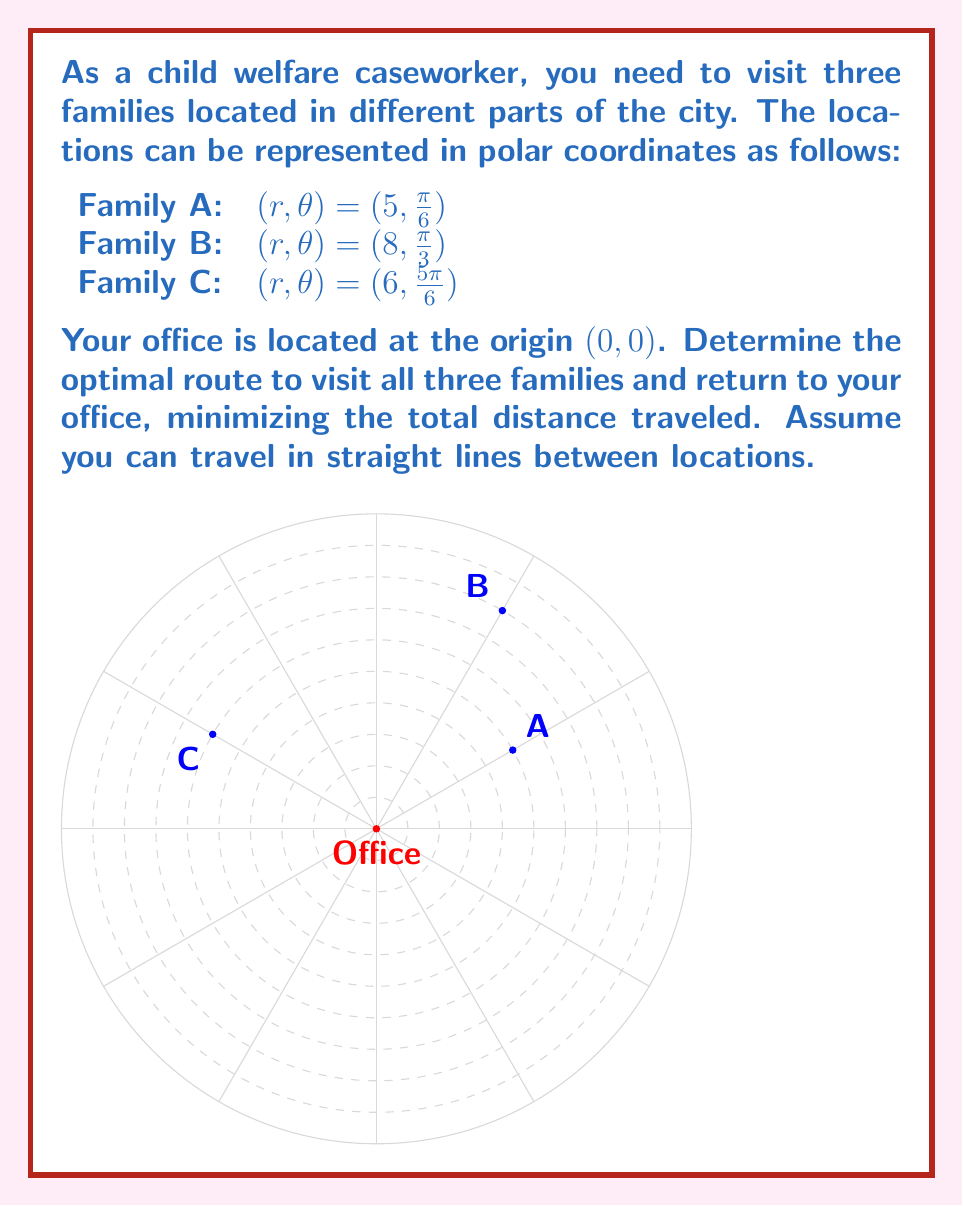Teach me how to tackle this problem. To solve this problem, we need to calculate the distances between all points and determine the shortest route. Let's follow these steps:

1) First, convert polar coordinates to Cartesian coordinates:
   Office: $(0, 0)$
   A: $(x_A, y_A) = (5\cos(\frac{\pi}{6}), 5\sin(\frac{\pi}{6})) \approx (4.33, 2.5)$
   B: $(x_B, y_B) = (8\cos(\frac{\pi}{3}), 8\sin(\frac{\pi}{3})) \approx (4, 6.93)$
   C: $(x_C, y_C) = (6\cos(\frac{5\pi}{6}), 6\sin(\frac{5\pi}{6})) \approx (-5.2, 3)$

2) Calculate distances between all points using the distance formula:
   $d = \sqrt{(x_2-x_1)^2 + (y_2-y_1)^2}$

   Office to A: $d_{OA} = 5$
   Office to B: $d_{OB} = 8$
   Office to C: $d_{OC} = 6$
   A to B: $d_{AB} = \sqrt{(4-4.33)^2 + (6.93-2.5)^2} \approx 4.47$
   B to C: $d_{BC} = \sqrt{(-5.2-4)^2 + (3-6.93)^2} \approx 9.85$
   C to A: $d_{CA} = \sqrt{(4.33+5.2)^2 + (2.5-3)^2} \approx 9.54$

3) Consider all possible routes:
   O-A-B-C-O: $5 + 4.47 + 9.85 + 6 = 25.32$
   O-A-C-B-O: $5 + 9.54 + 9.85 + 8 = 32.39$
   O-B-A-C-O: $8 + 4.47 + 9.54 + 6 = 28.01$
   O-B-C-A-O: $8 + 9.85 + 9.54 + 5 = 32.39$
   O-C-A-B-O: $6 + 9.54 + 4.47 + 8 = 28.01$
   O-C-B-A-O: $6 + 9.85 + 4.47 + 5 = 25.32$

4) The optimal routes are O-A-B-C-O and O-C-B-A-O, both with a total distance of 25.32 units.
Answer: Office-A-B-C-Office or Office-C-B-A-Office, 25.32 units 